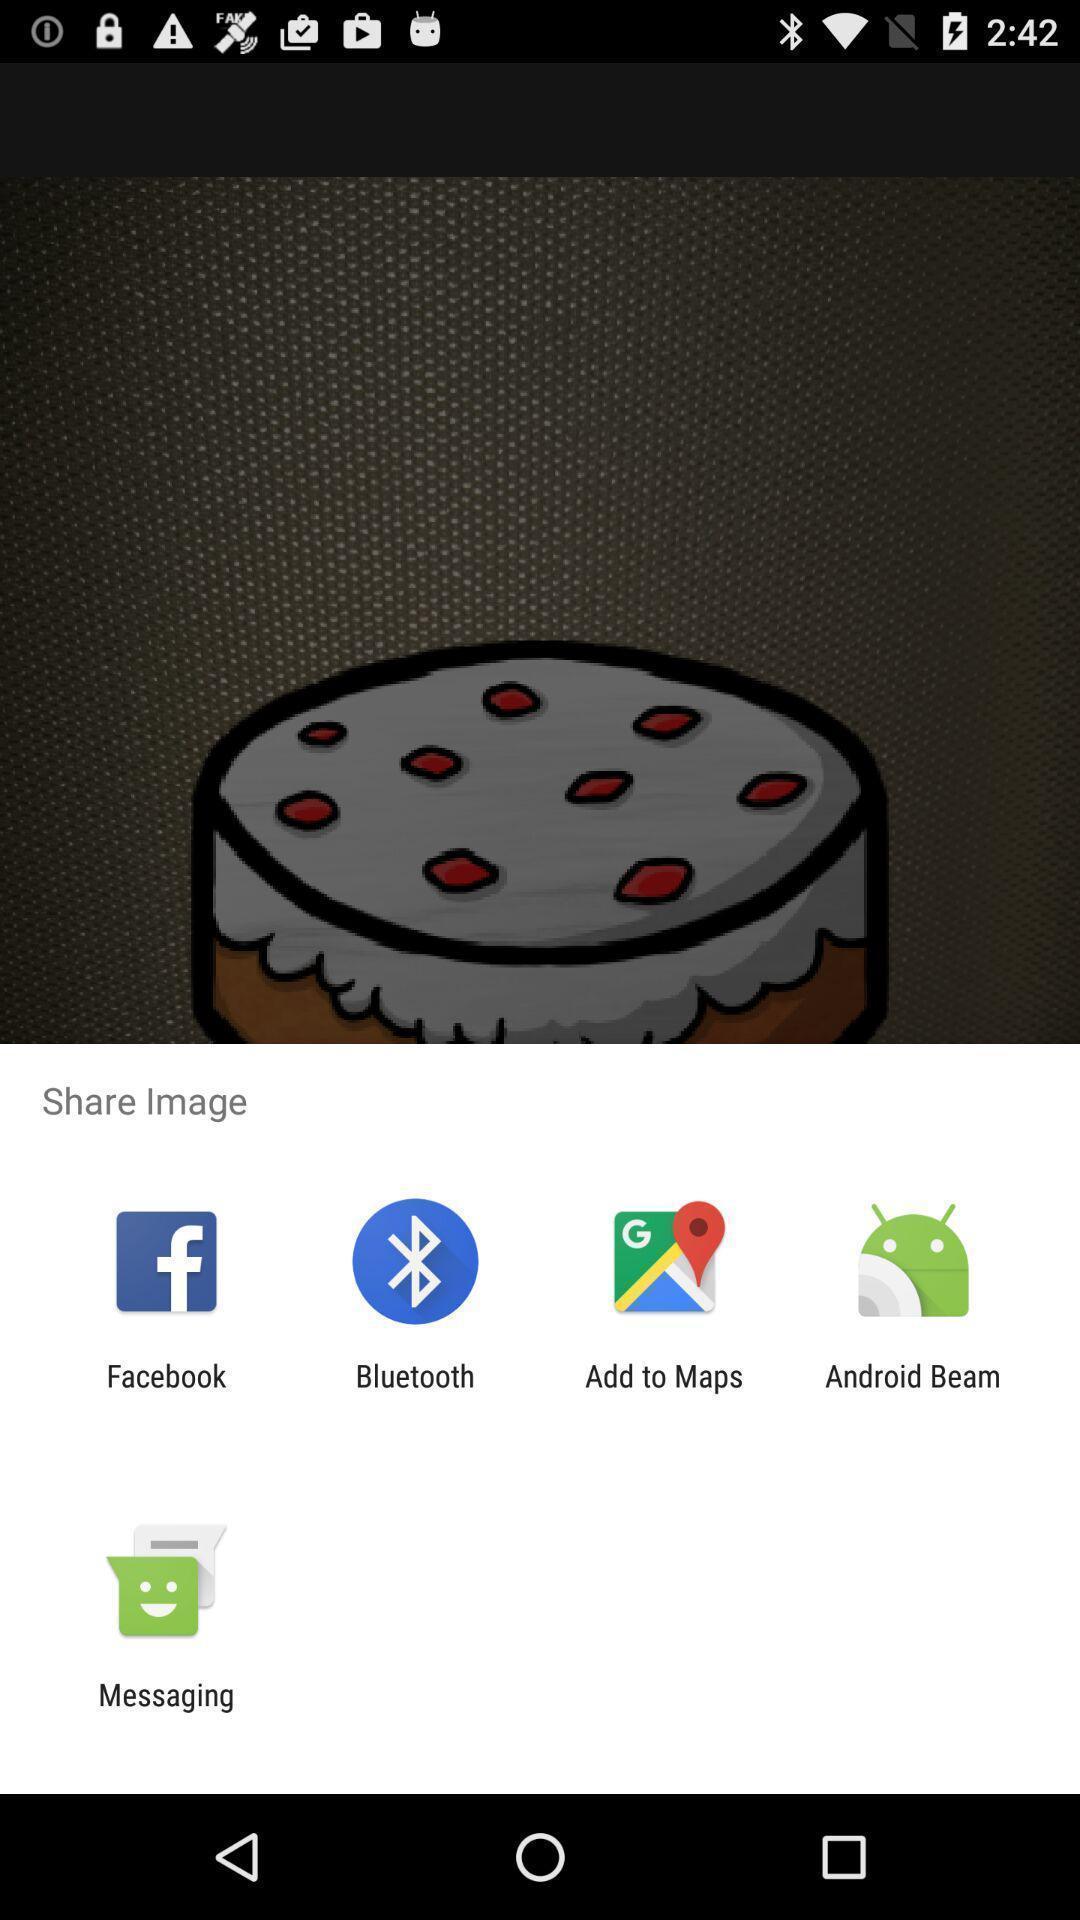Tell me about the visual elements in this screen capture. Pop up to share image with different applications. 